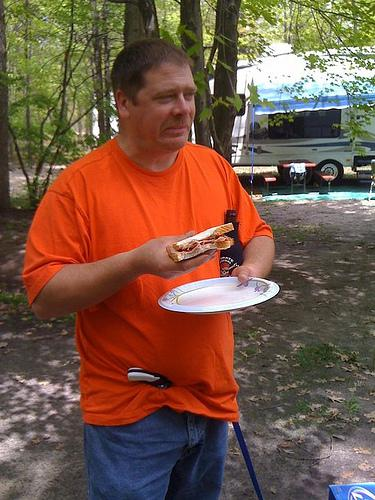Question: what is in the background?
Choices:
A. A trailer.
B. A mountain.
C. A golf course.
D. A shopping center.
Answer with the letter. Answer: A Question: where is the man?
Choices:
A. In the car.
B. In the woods.
C. On the path.
D. In the truck.
Answer with the letter. Answer: B Question: what is the man eating on?
Choices:
A. A table.
B. A tray.
C. Paper plate.
D. A dash.
Answer with the letter. Answer: C Question: what pants is the man wearing?
Choices:
A. Black slacks.
B. Kahkis.
C. Jeans.
D. Carpenter pants.
Answer with the letter. Answer: C Question: what color shirt is that?
Choices:
A. Red.
B. Pink.
C. Orange.
D. Blue.
Answer with the letter. Answer: C Question: what color pants is that?
Choices:
A. White.
B. Beige.
C. Black.
D. Blue.
Answer with the letter. Answer: D Question: what is the man doing?
Choices:
A. Walking.
B. Eating.
C. Sleeping.
D. Reading.
Answer with the letter. Answer: B 